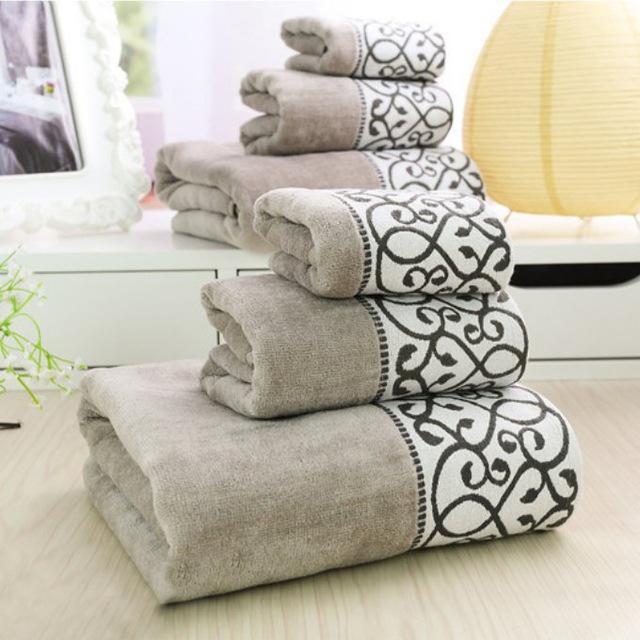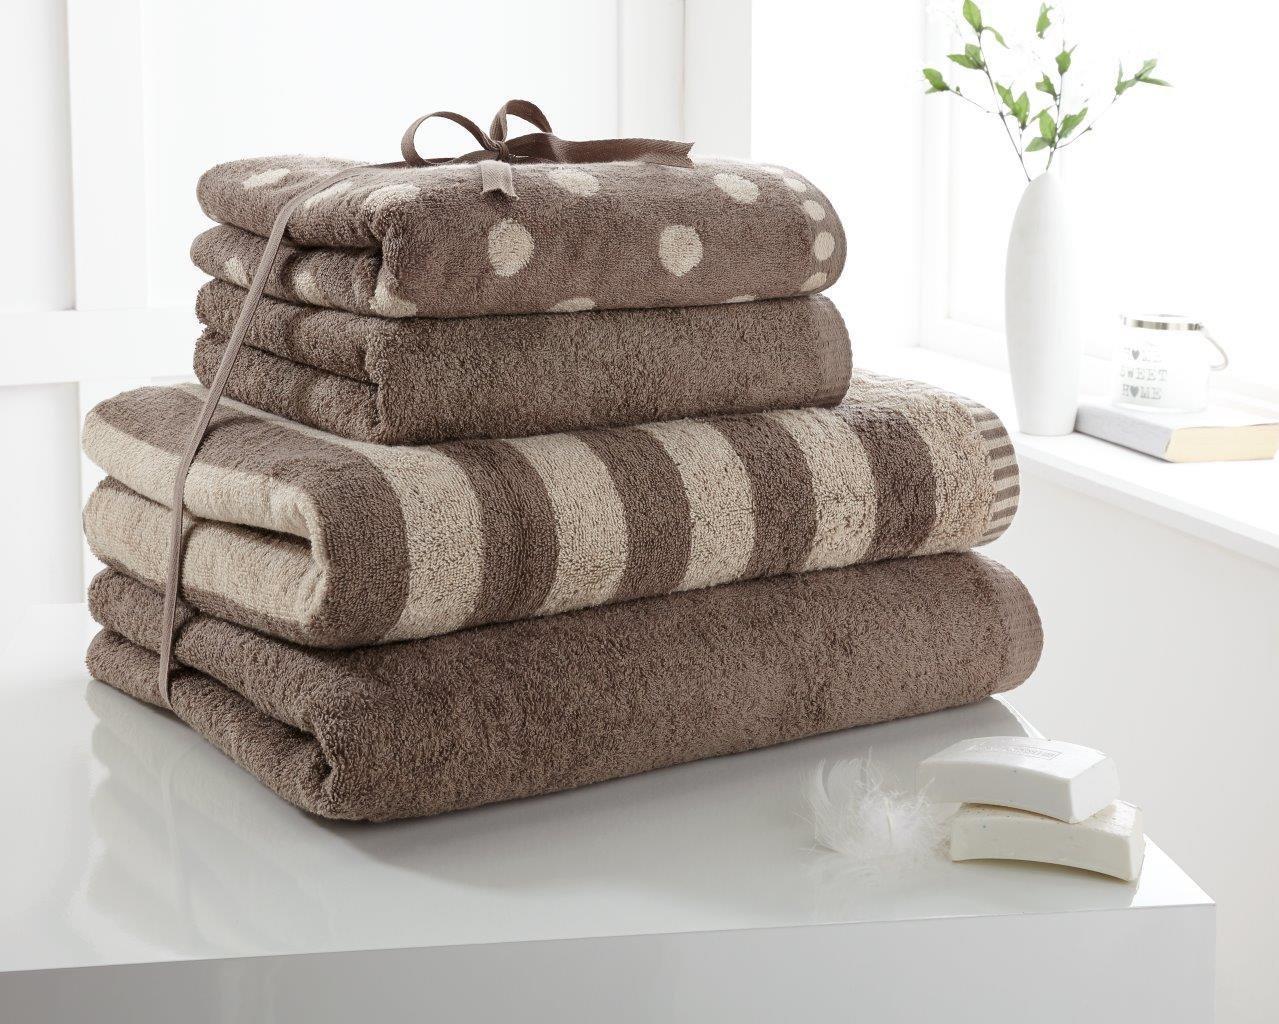The first image is the image on the left, the second image is the image on the right. For the images displayed, is the sentence "There are at least two very light brown towels with its top half white with S looking vines sewn into it." factually correct? Answer yes or no. Yes. The first image is the image on the left, the second image is the image on the right. Considering the images on both sides, is "There is a stack of towels on the right." valid? Answer yes or no. Yes. 